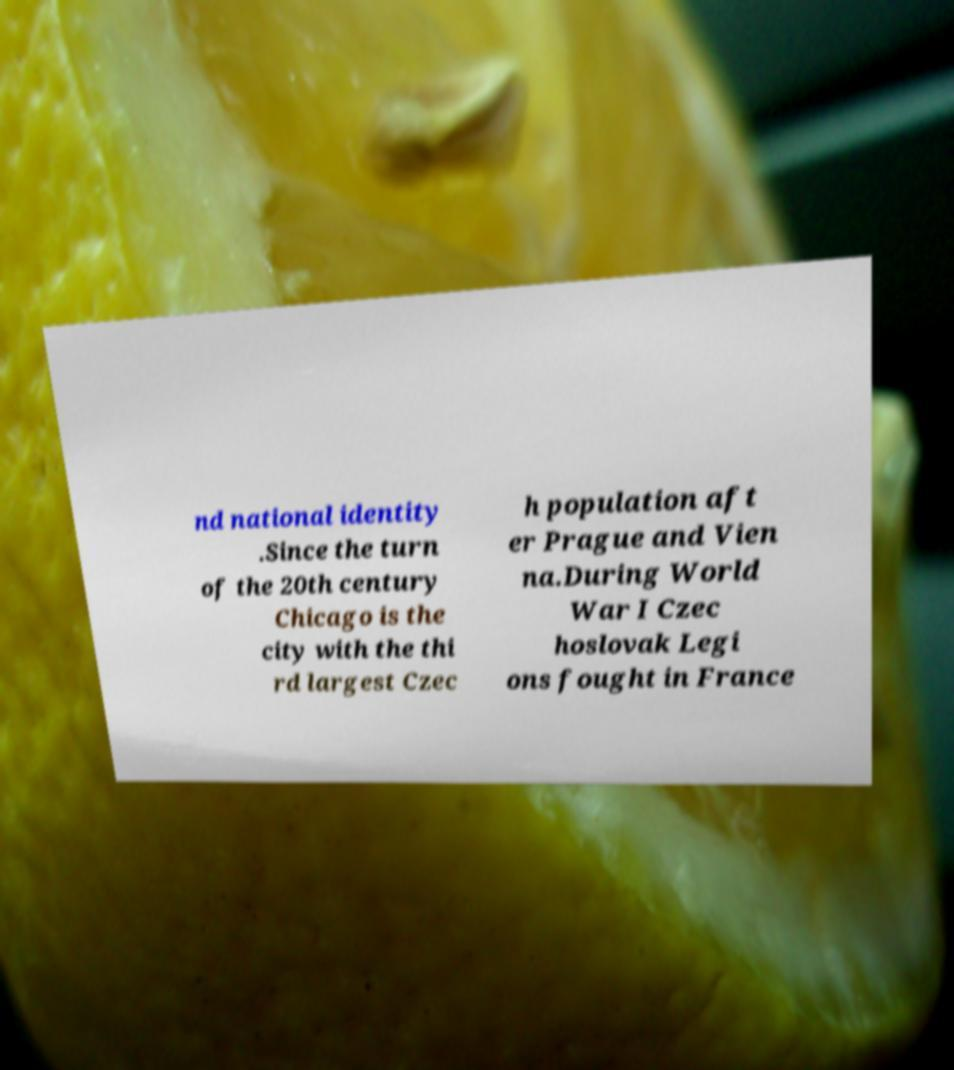There's text embedded in this image that I need extracted. Can you transcribe it verbatim? nd national identity .Since the turn of the 20th century Chicago is the city with the thi rd largest Czec h population aft er Prague and Vien na.During World War I Czec hoslovak Legi ons fought in France 